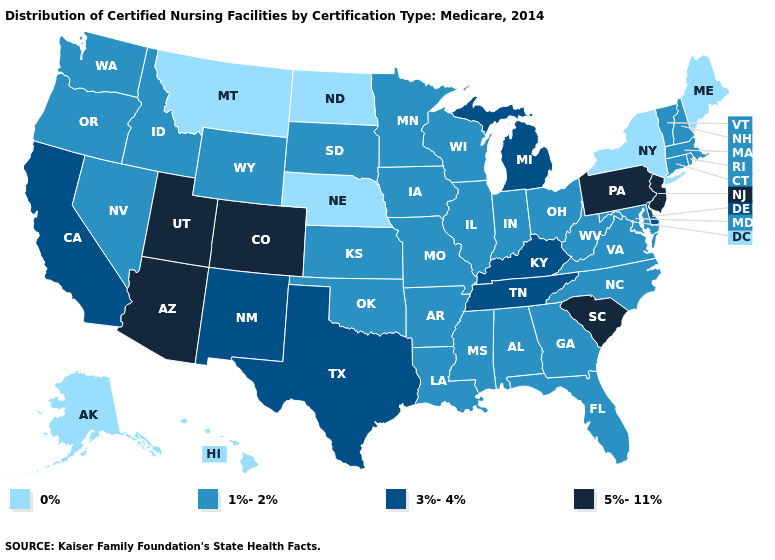Name the states that have a value in the range 0%?
Answer briefly. Alaska, Hawaii, Maine, Montana, Nebraska, New York, North Dakota. Name the states that have a value in the range 1%-2%?
Quick response, please. Alabama, Arkansas, Connecticut, Florida, Georgia, Idaho, Illinois, Indiana, Iowa, Kansas, Louisiana, Maryland, Massachusetts, Minnesota, Mississippi, Missouri, Nevada, New Hampshire, North Carolina, Ohio, Oklahoma, Oregon, Rhode Island, South Dakota, Vermont, Virginia, Washington, West Virginia, Wisconsin, Wyoming. What is the value of Florida?
Answer briefly. 1%-2%. What is the highest value in the USA?
Give a very brief answer. 5%-11%. Which states hav the highest value in the West?
Give a very brief answer. Arizona, Colorado, Utah. Among the states that border Vermont , which have the lowest value?
Keep it brief. New York. What is the value of Washington?
Be succinct. 1%-2%. What is the value of Hawaii?
Keep it brief. 0%. Does North Carolina have the lowest value in the South?
Be succinct. Yes. Name the states that have a value in the range 0%?
Concise answer only. Alaska, Hawaii, Maine, Montana, Nebraska, New York, North Dakota. Among the states that border Wyoming , which have the lowest value?
Answer briefly. Montana, Nebraska. Which states have the lowest value in the West?
Answer briefly. Alaska, Hawaii, Montana. How many symbols are there in the legend?
Quick response, please. 4. Among the states that border West Virginia , which have the lowest value?
Write a very short answer. Maryland, Ohio, Virginia. Which states have the lowest value in the USA?
Keep it brief. Alaska, Hawaii, Maine, Montana, Nebraska, New York, North Dakota. 